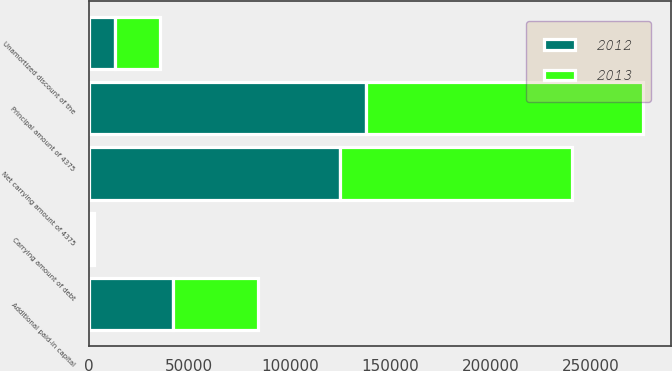<chart> <loc_0><loc_0><loc_500><loc_500><stacked_bar_chart><ecel><fcel>Additional paid-in capital<fcel>Principal amount of 4375<fcel>Unamortized discount of the<fcel>Net carrying amount of 4375<fcel>Carrying amount of debt<nl><fcel>2012<fcel>42018<fcel>138000<fcel>12819<fcel>125181<fcel>797<nl><fcel>2013<fcel>42018<fcel>138000<fcel>22369<fcel>115631<fcel>1479<nl></chart> 